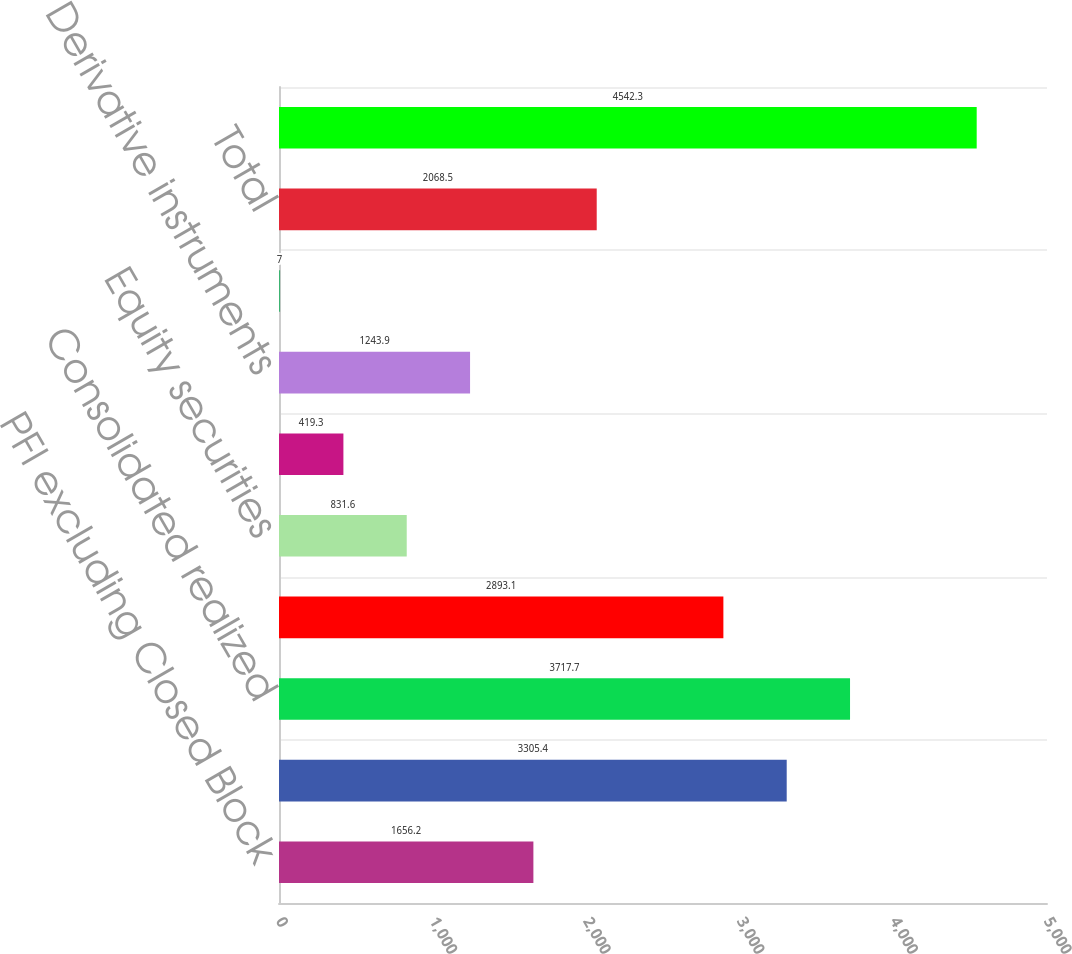Convert chart. <chart><loc_0><loc_0><loc_500><loc_500><bar_chart><fcel>PFI excluding Closed Block<fcel>Closed Block division<fcel>Consolidated realized<fcel>Fixed maturity securities<fcel>Equity securities<fcel>Commercial mortgage and other<fcel>Derivative instruments<fcel>Other<fcel>Total<fcel>Related adjustments<nl><fcel>1656.2<fcel>3305.4<fcel>3717.7<fcel>2893.1<fcel>831.6<fcel>419.3<fcel>1243.9<fcel>7<fcel>2068.5<fcel>4542.3<nl></chart> 